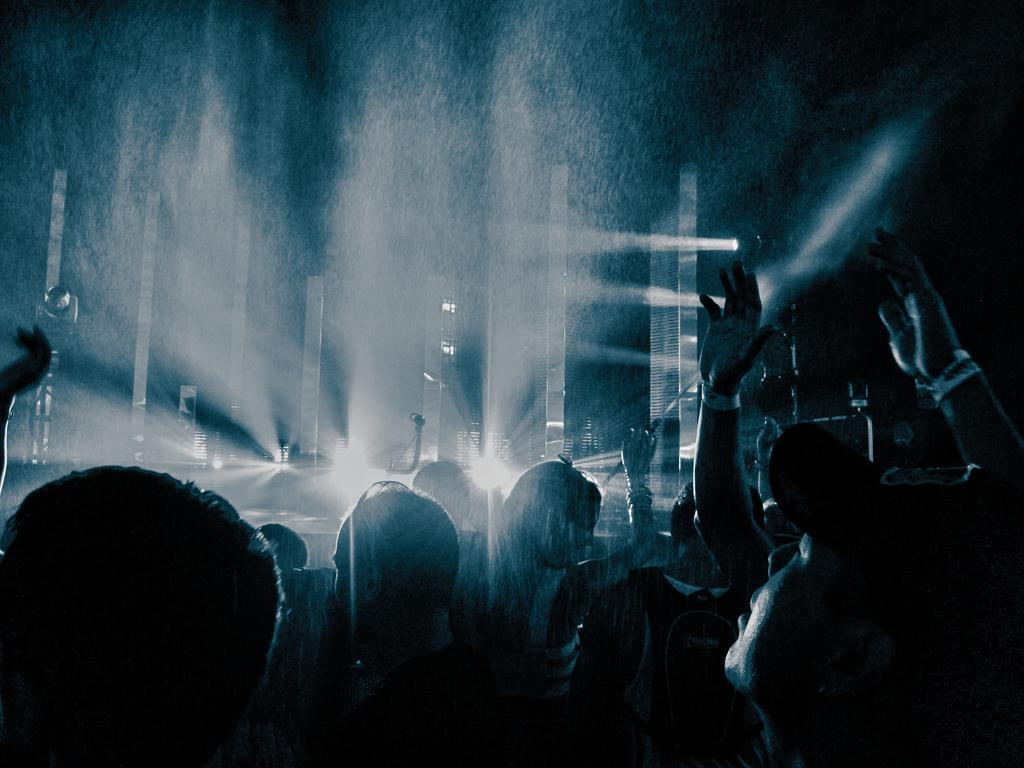Who or what is present in the image? There are people in the image. Where are the people located in the image? The people are at the bottom of the image. What can be seen in the background of the image? There are lights in the background of the image. How would you describe the overall lighting in the image? The background of the image is dark. What type of grain can be seen growing near the coast in the image? There is no grain or coast present in the image; it features people at the bottom with a dark background and lights in the distance. 